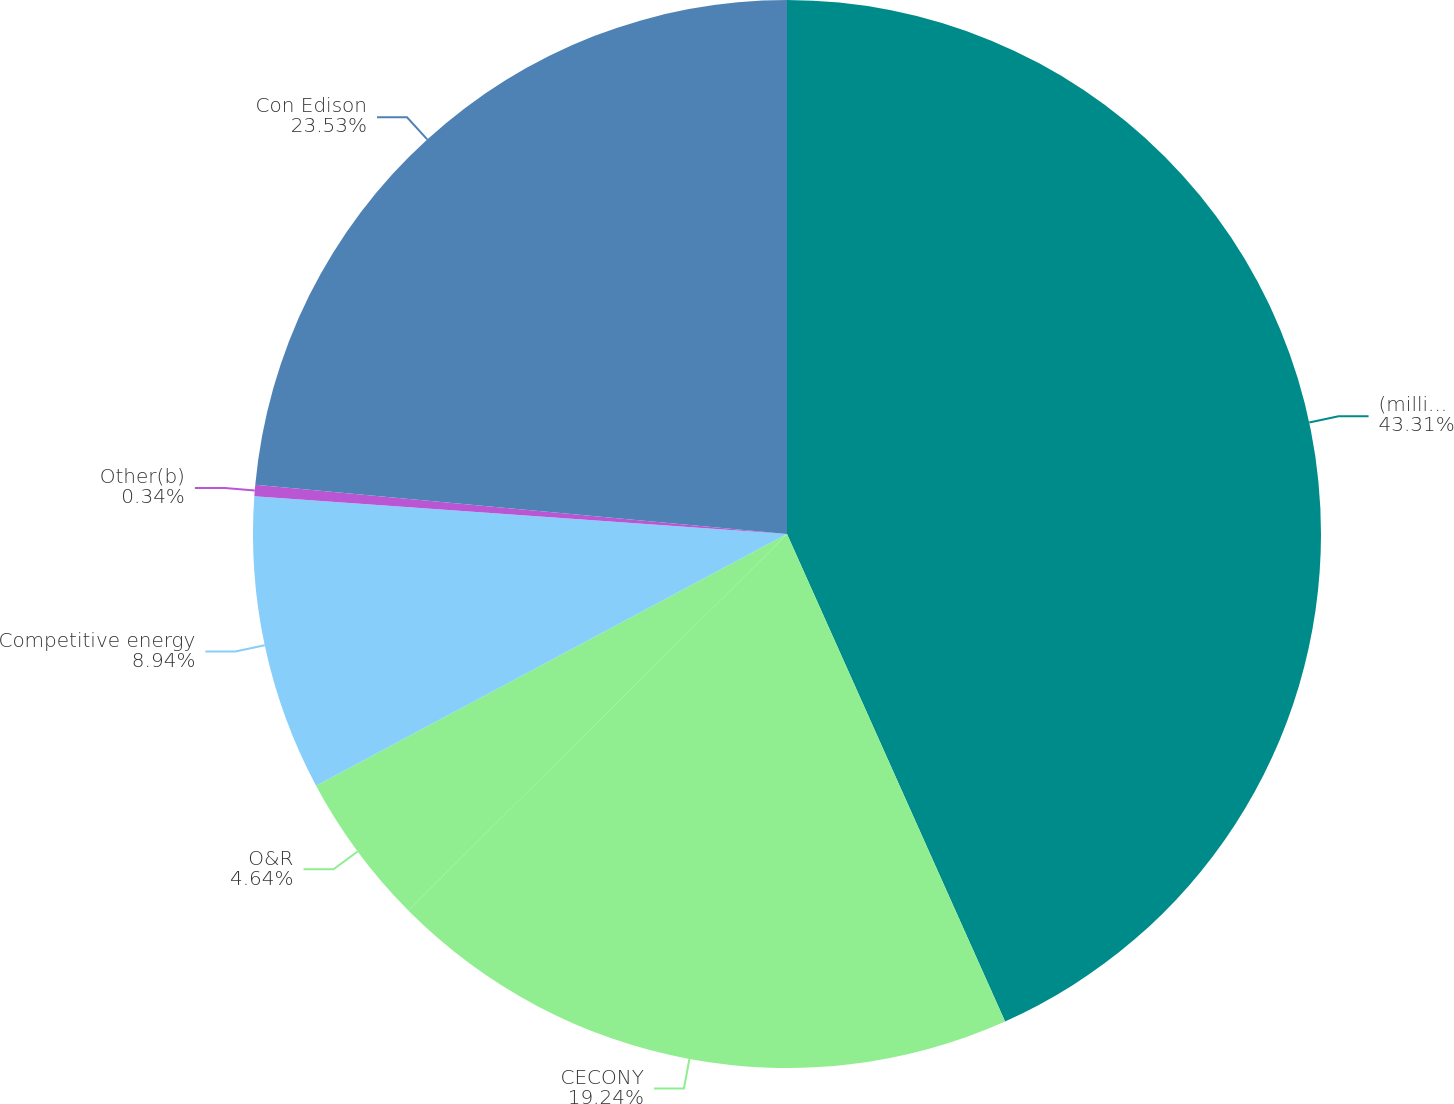<chart> <loc_0><loc_0><loc_500><loc_500><pie_chart><fcel>(millions of dollars)<fcel>CECONY<fcel>O&R<fcel>Competitive energy<fcel>Other(b)<fcel>Con Edison<nl><fcel>43.3%<fcel>19.24%<fcel>4.64%<fcel>8.94%<fcel>0.34%<fcel>23.53%<nl></chart> 